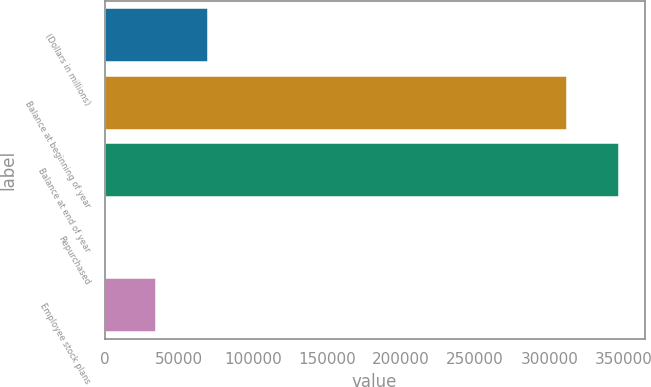Convert chart to OTSL. <chart><loc_0><loc_0><loc_500><loc_500><bar_chart><fcel>(Dollars in millions)<fcel>Balance at beginning of year<fcel>Balance at end of year<fcel>Repurchased<fcel>Employee stock plans<nl><fcel>69442.8<fcel>312166<fcel>346825<fcel>124<fcel>34783.4<nl></chart> 